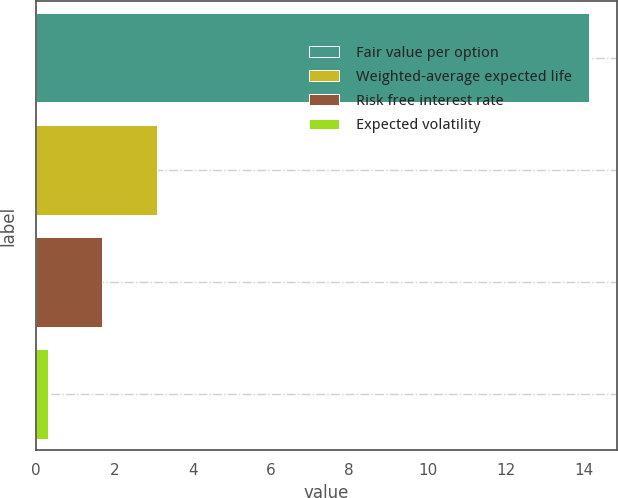<chart> <loc_0><loc_0><loc_500><loc_500><bar_chart><fcel>Fair value per option<fcel>Weighted-average expected life<fcel>Risk free interest rate<fcel>Expected volatility<nl><fcel>14.12<fcel>3.1<fcel>1.68<fcel>0.3<nl></chart> 